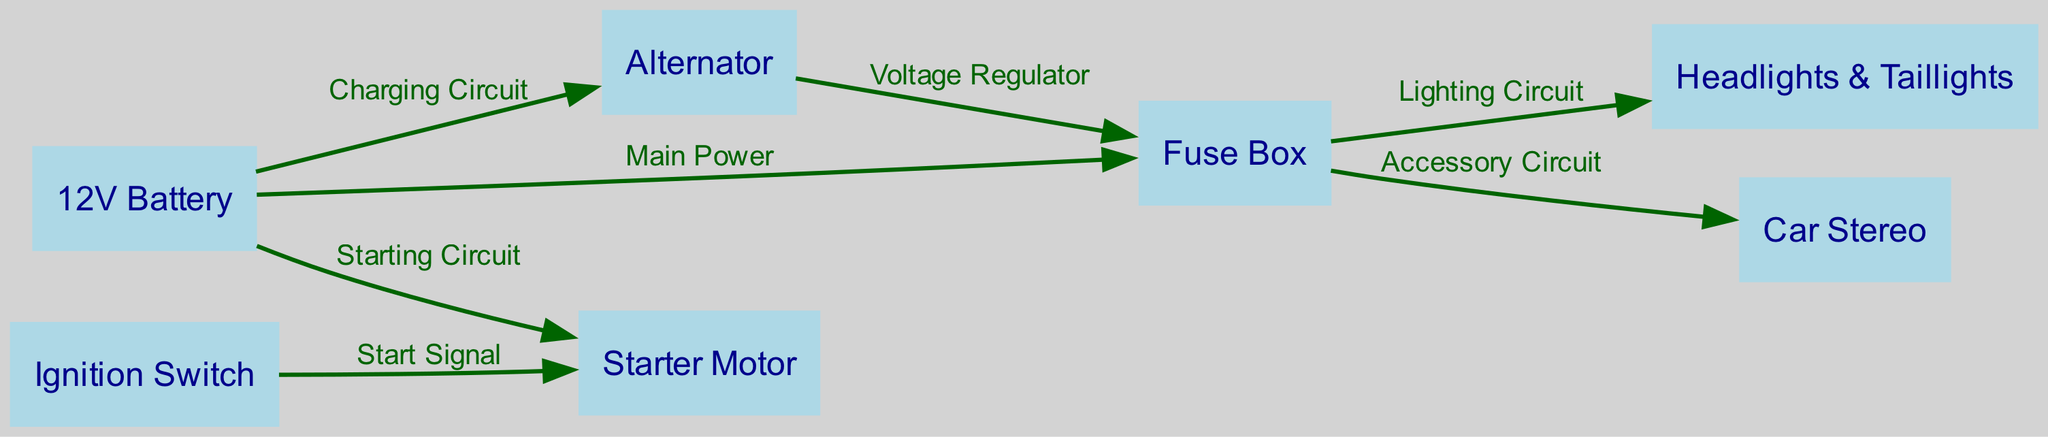What is the main power source of the car's electrical system? The diagram indicates that the "12V Battery" is the source supplying "Main Power" to the "Fuse Box." This connection shows that the battery acts as the primary power source for the electrical system.
Answer: 12V Battery How many nodes are present in this diagram? By counting the distinct elements in the nodes list, we identify that there are seven nodes: Battery, Alternator, Fuse Box, Starter Motor, Ignition Switch, Headlights & Taillights, and Car Stereo. Thus, the answer is derived from the total count of nodes provided.
Answer: 7 What connects the battery to the starter motor? The "Starting Circuit" connects the "12V Battery" directly to the "Starter Motor." The label on the edge clearly shows this relationship, indicating how power flows from the battery to the starter during engine start-up.
Answer: Starting Circuit Which components are powered by the fuse box? The "Fuse Box" distributes power to "Headlights & Taillights" and "Car Stereo" as indicated by the arrows connected from the fuse box to these components. This investigation involves checking edges leaving the fuse box.
Answer: Headlights & Taillights, Car Stereo What is the purpose of the Alternator in this diagram? The "Alternator" serves to provide a "Charging Circuit" to the "12V Battery," as well as additional connections to the "Fuse Box" for voltage regulation. The flow of information suggests that the alternator is responsible for recharging the battery and managing voltage supply.
Answer: Charging Circuit, Voltage Regulator How does the ignition switch interact with the starter motor? The "Ignition Switch" is connected to the "Starter Motor" via a "Start Signal," as noted in the edges linking these nodes. This connection indicates that when the ignition switch is activated, it sends a signal to the starter motor to start the engine.
Answer: Start Signal What type of signal is sent from the ignition switch? The edge between the "Ignition Switch" and "Starter Motor" is labeled "Start Signal." This label identifies the nature of the signal being transmitted from the ignition switch to initiate the starter motor.
Answer: Start Signal Which electrical component regulates voltage to the fuse box? The "Alternator" connects to the "Fuse Box" and is labeled as the source of the "Voltage Regulator." This shows that the alternator ensures the voltage supplied to the fuse box is within the correct range.
Answer: Voltage Regulator What connects the battery to the alternator? The connection from the "12V Battery" to the "Alternator" is labeled as the "Charging Circuit." This indicates how the battery is charged and how current flows between these two components.
Answer: Charging Circuit 